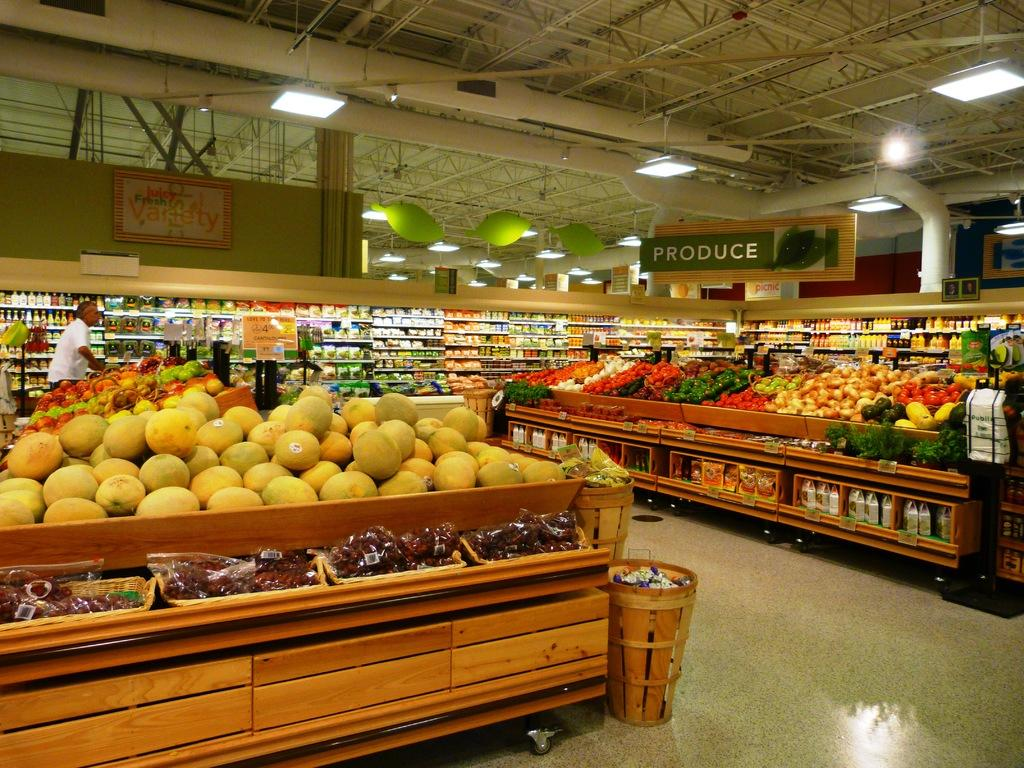<image>
Summarize the visual content of the image. Supermarket selling many types of fruits and a sign saying Produce. 